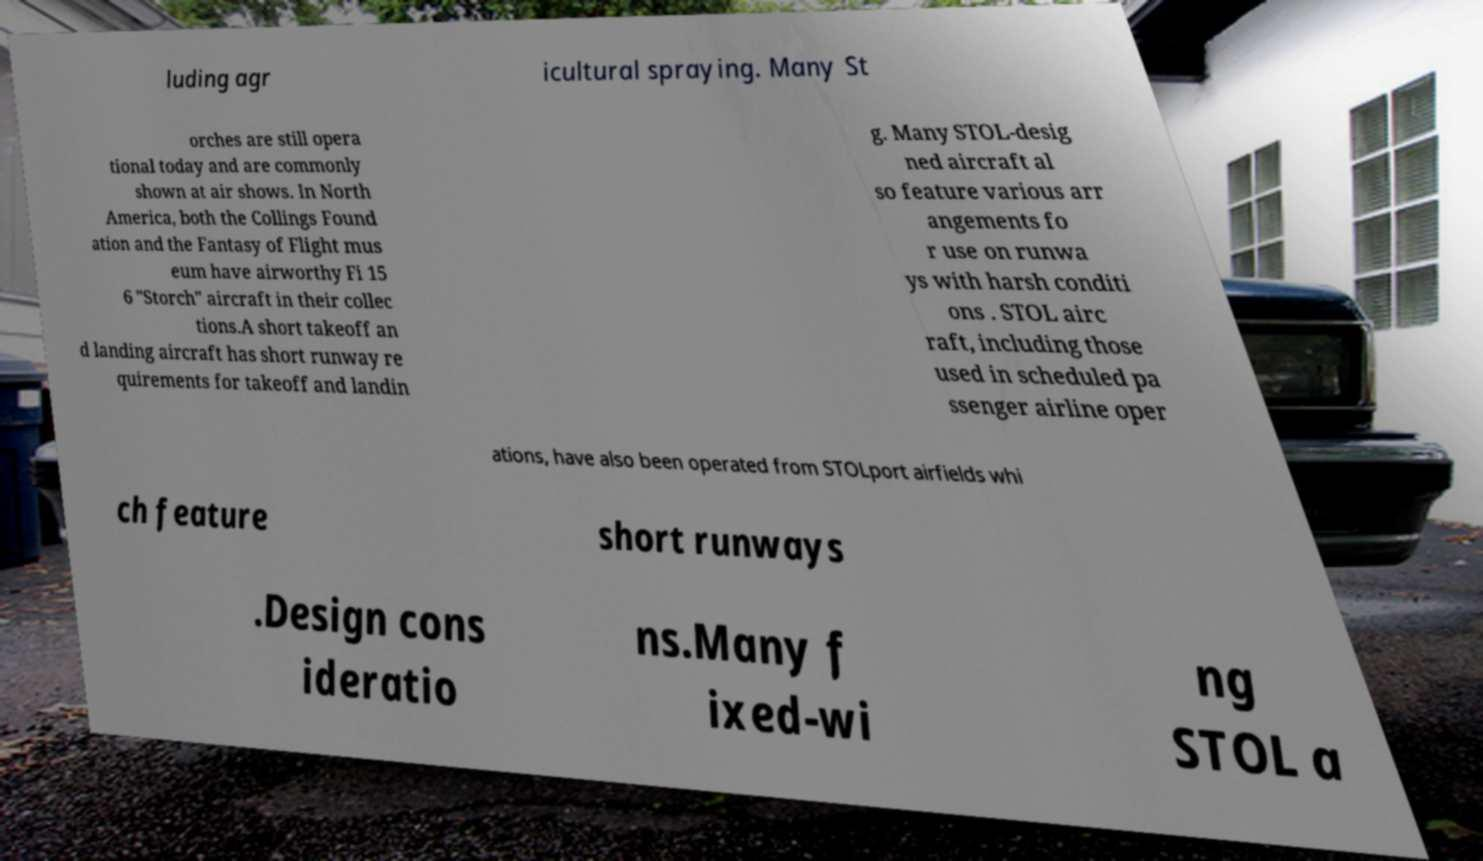I need the written content from this picture converted into text. Can you do that? luding agr icultural spraying. Many St orches are still opera tional today and are commonly shown at air shows. In North America, both the Collings Found ation and the Fantasy of Flight mus eum have airworthy Fi 15 6 "Storch" aircraft in their collec tions.A short takeoff an d landing aircraft has short runway re quirements for takeoff and landin g. Many STOL-desig ned aircraft al so feature various arr angements fo r use on runwa ys with harsh conditi ons . STOL airc raft, including those used in scheduled pa ssenger airline oper ations, have also been operated from STOLport airfields whi ch feature short runways .Design cons ideratio ns.Many f ixed-wi ng STOL a 